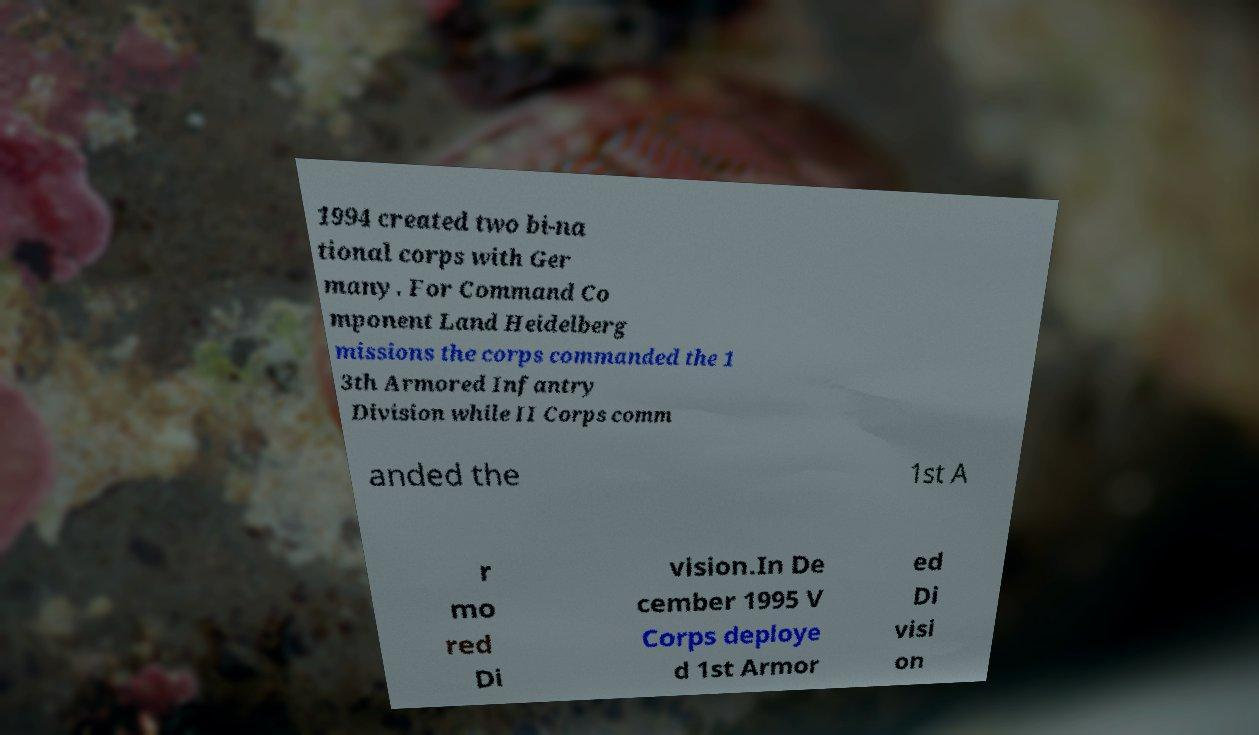Can you accurately transcribe the text from the provided image for me? 1994 created two bi-na tional corps with Ger many. For Command Co mponent Land Heidelberg missions the corps commanded the 1 3th Armored Infantry Division while II Corps comm anded the 1st A r mo red Di vision.In De cember 1995 V Corps deploye d 1st Armor ed Di visi on 